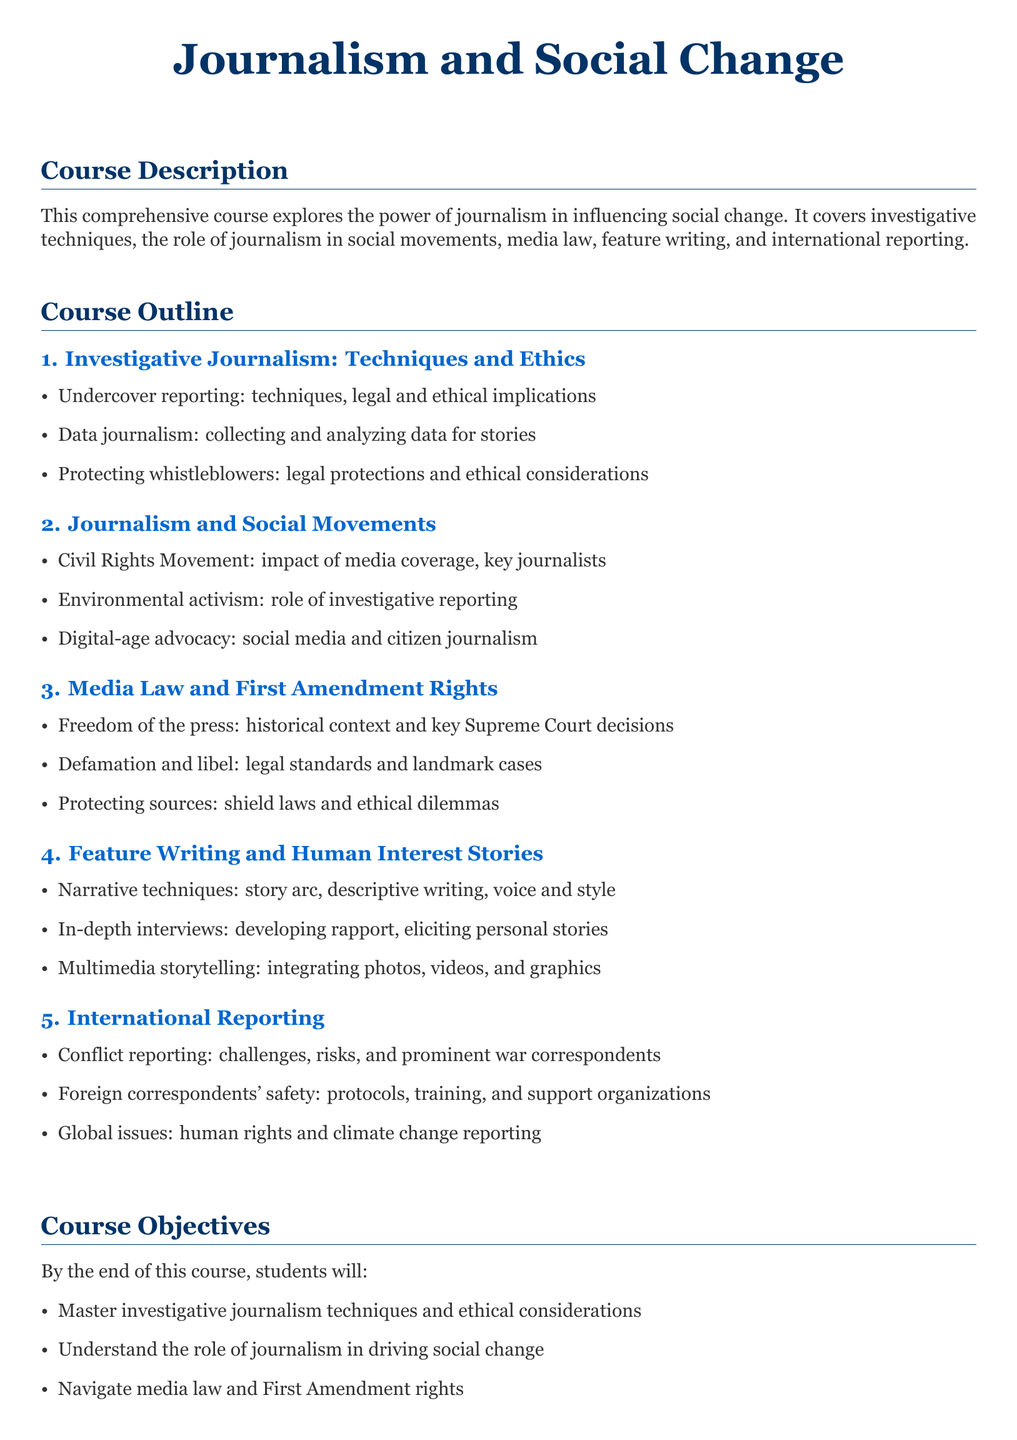what is the title of the syllabus? The title of the syllabus is stated at the beginning of the document, highlighting its theme.
Answer: Journalism and Social Change how many sections are in the course outline? The course outline consists of five sections, detailing different areas of journalism.
Answer: 5 what is the first topic covered in Investigative Journalism? The first topic is listed under the Investigative Journalism section, focusing on a specific technique.
Answer: Undercover reporting what is one of the course objectives? The objectives are listed at the end of the syllabus, focusing on skills students will master.
Answer: Master investigative journalism techniques and ethical considerations what historical movement is mentioned in the Journalism and Social Movements section? The section lists key historical events that were supported by journalism, one of which is notable.
Answer: Civil Rights Movement which skills are students expected to develop for international reporting? The course outlines the required skills for the international reporting section, indicating an area of focus.
Answer: Global issue analysis what is the primary focus of the third section? This section is centered around legal aspects relevant to journalism, highlighting a critical area of study.
Answer: Media Law and First Amendment Rights which narrative techniques are discussed in the Feature Writing section? The syllabus specifies certain techniques that are essential for crafting compelling stories.
Answer: Story arc, descriptive writing, voice and style 